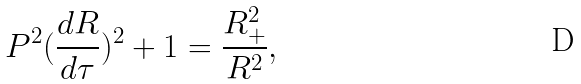Convert formula to latex. <formula><loc_0><loc_0><loc_500><loc_500>P ^ { 2 } ( \frac { d R } { d \tau } ) ^ { 2 } + 1 = \frac { R _ { + } ^ { 2 } } { R ^ { 2 } } ,</formula> 